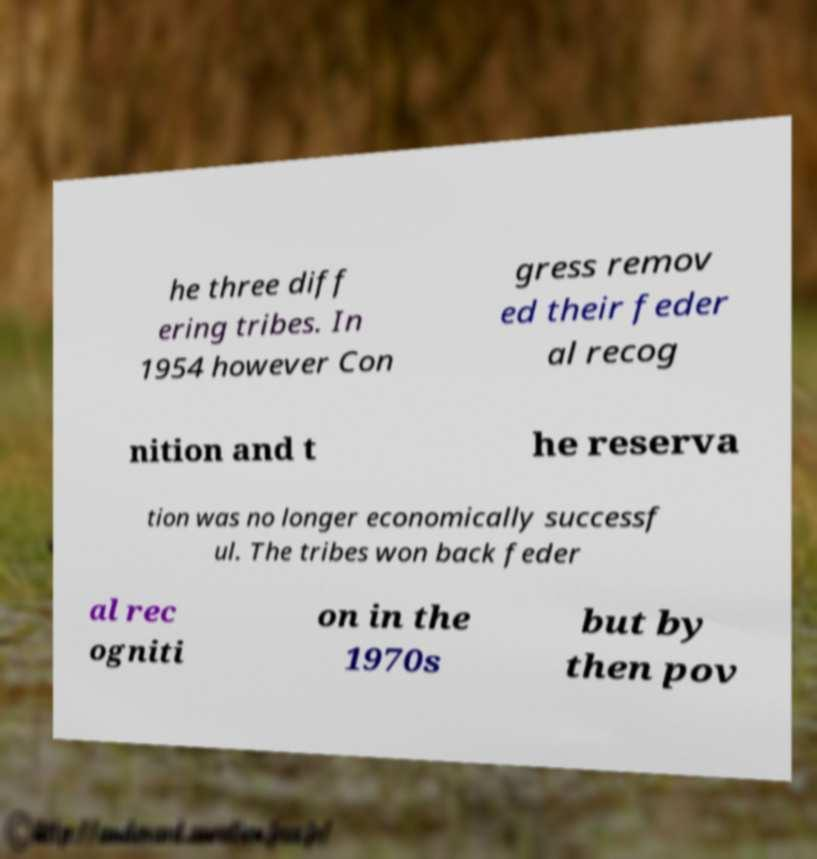I need the written content from this picture converted into text. Can you do that? he three diff ering tribes. In 1954 however Con gress remov ed their feder al recog nition and t he reserva tion was no longer economically successf ul. The tribes won back feder al rec ogniti on in the 1970s but by then pov 